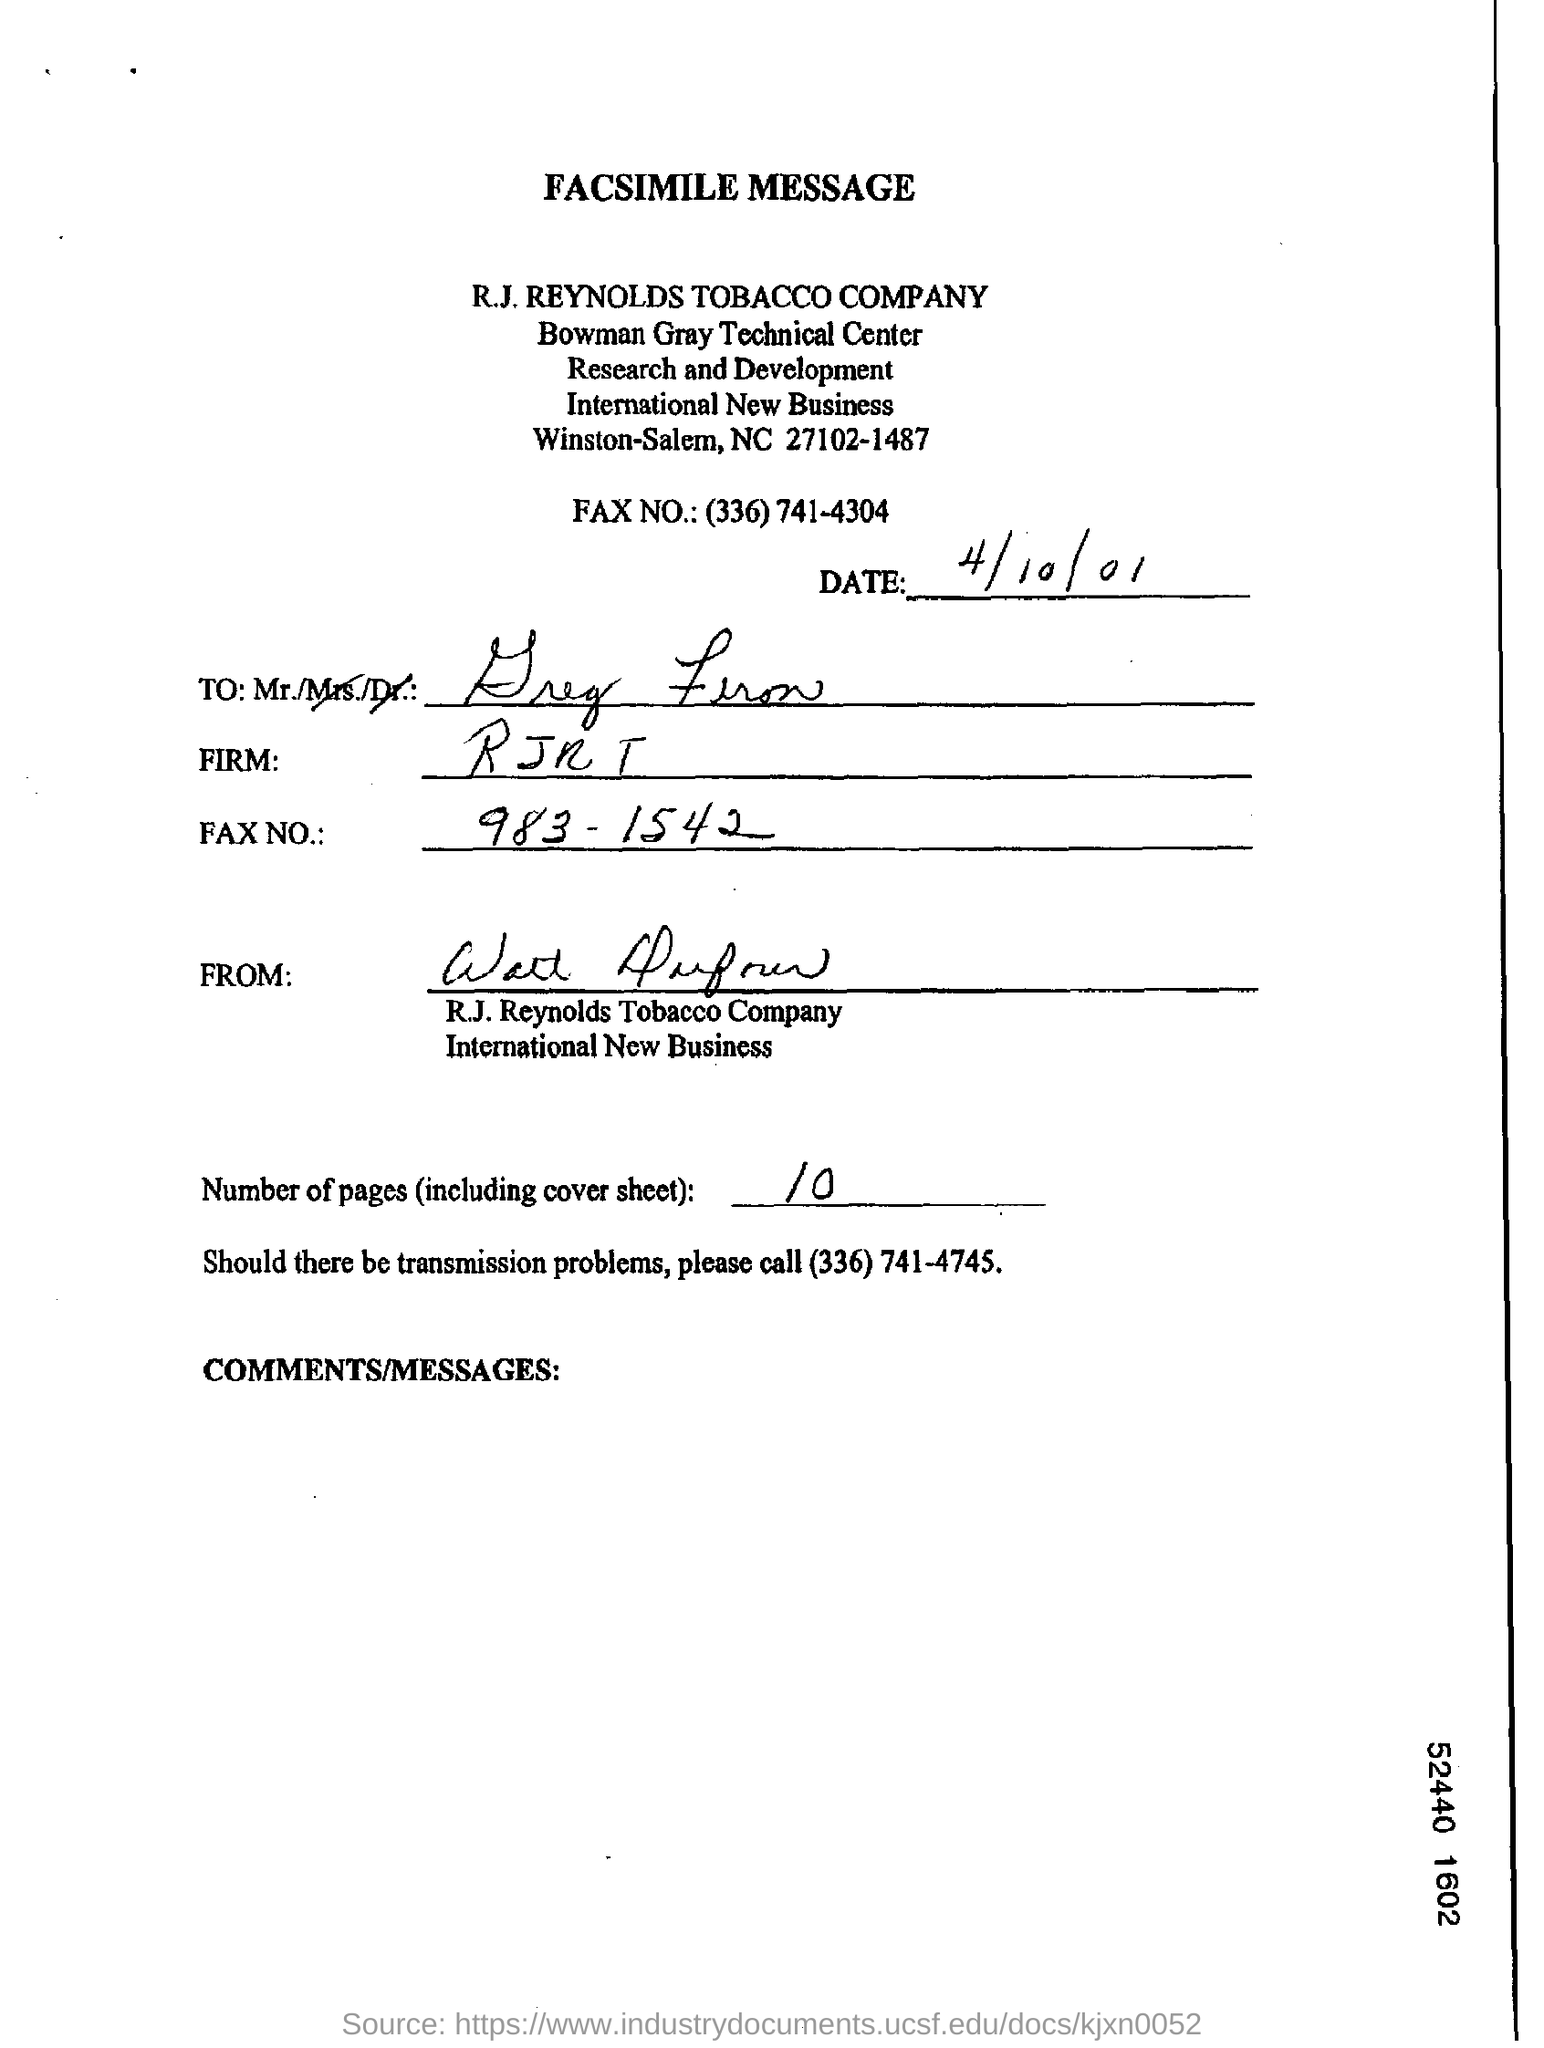What is the date on the document?
Offer a very short reply. 4/10/01. What are the Number of pages (including cover sheet)?
Offer a terse response. 10. 